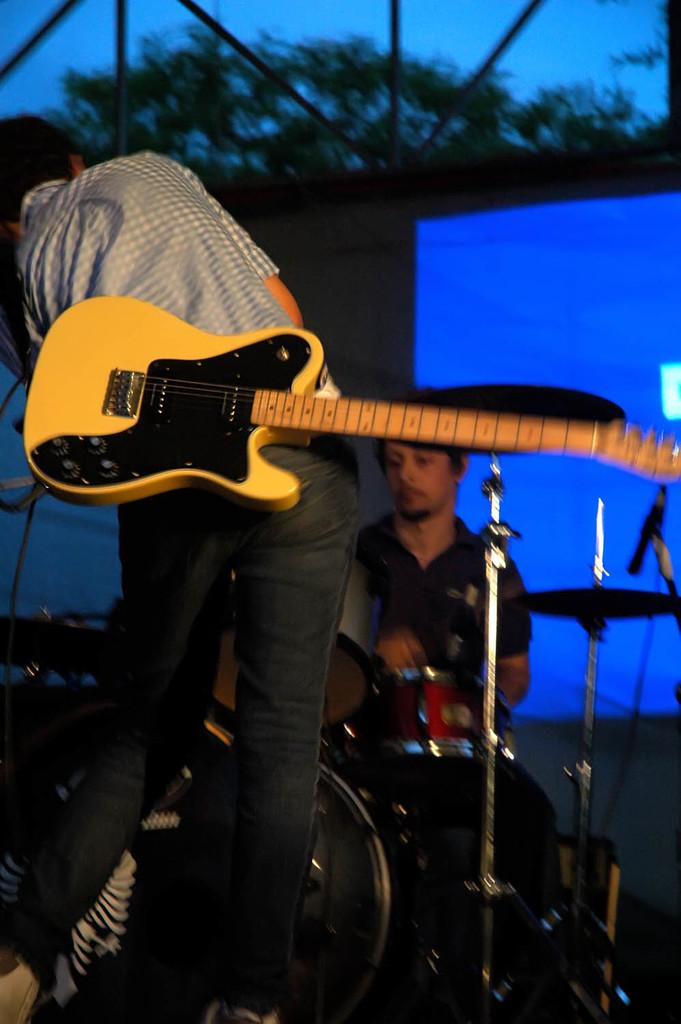How many people are in the image? There are two men in the image. What are the men doing in the image? The men are playing music. Where are the men located in the image? The men are on a stage. What type of bushes can be seen in the background of the image? There are no bushes visible in the image; it features two men playing music on a stage. 